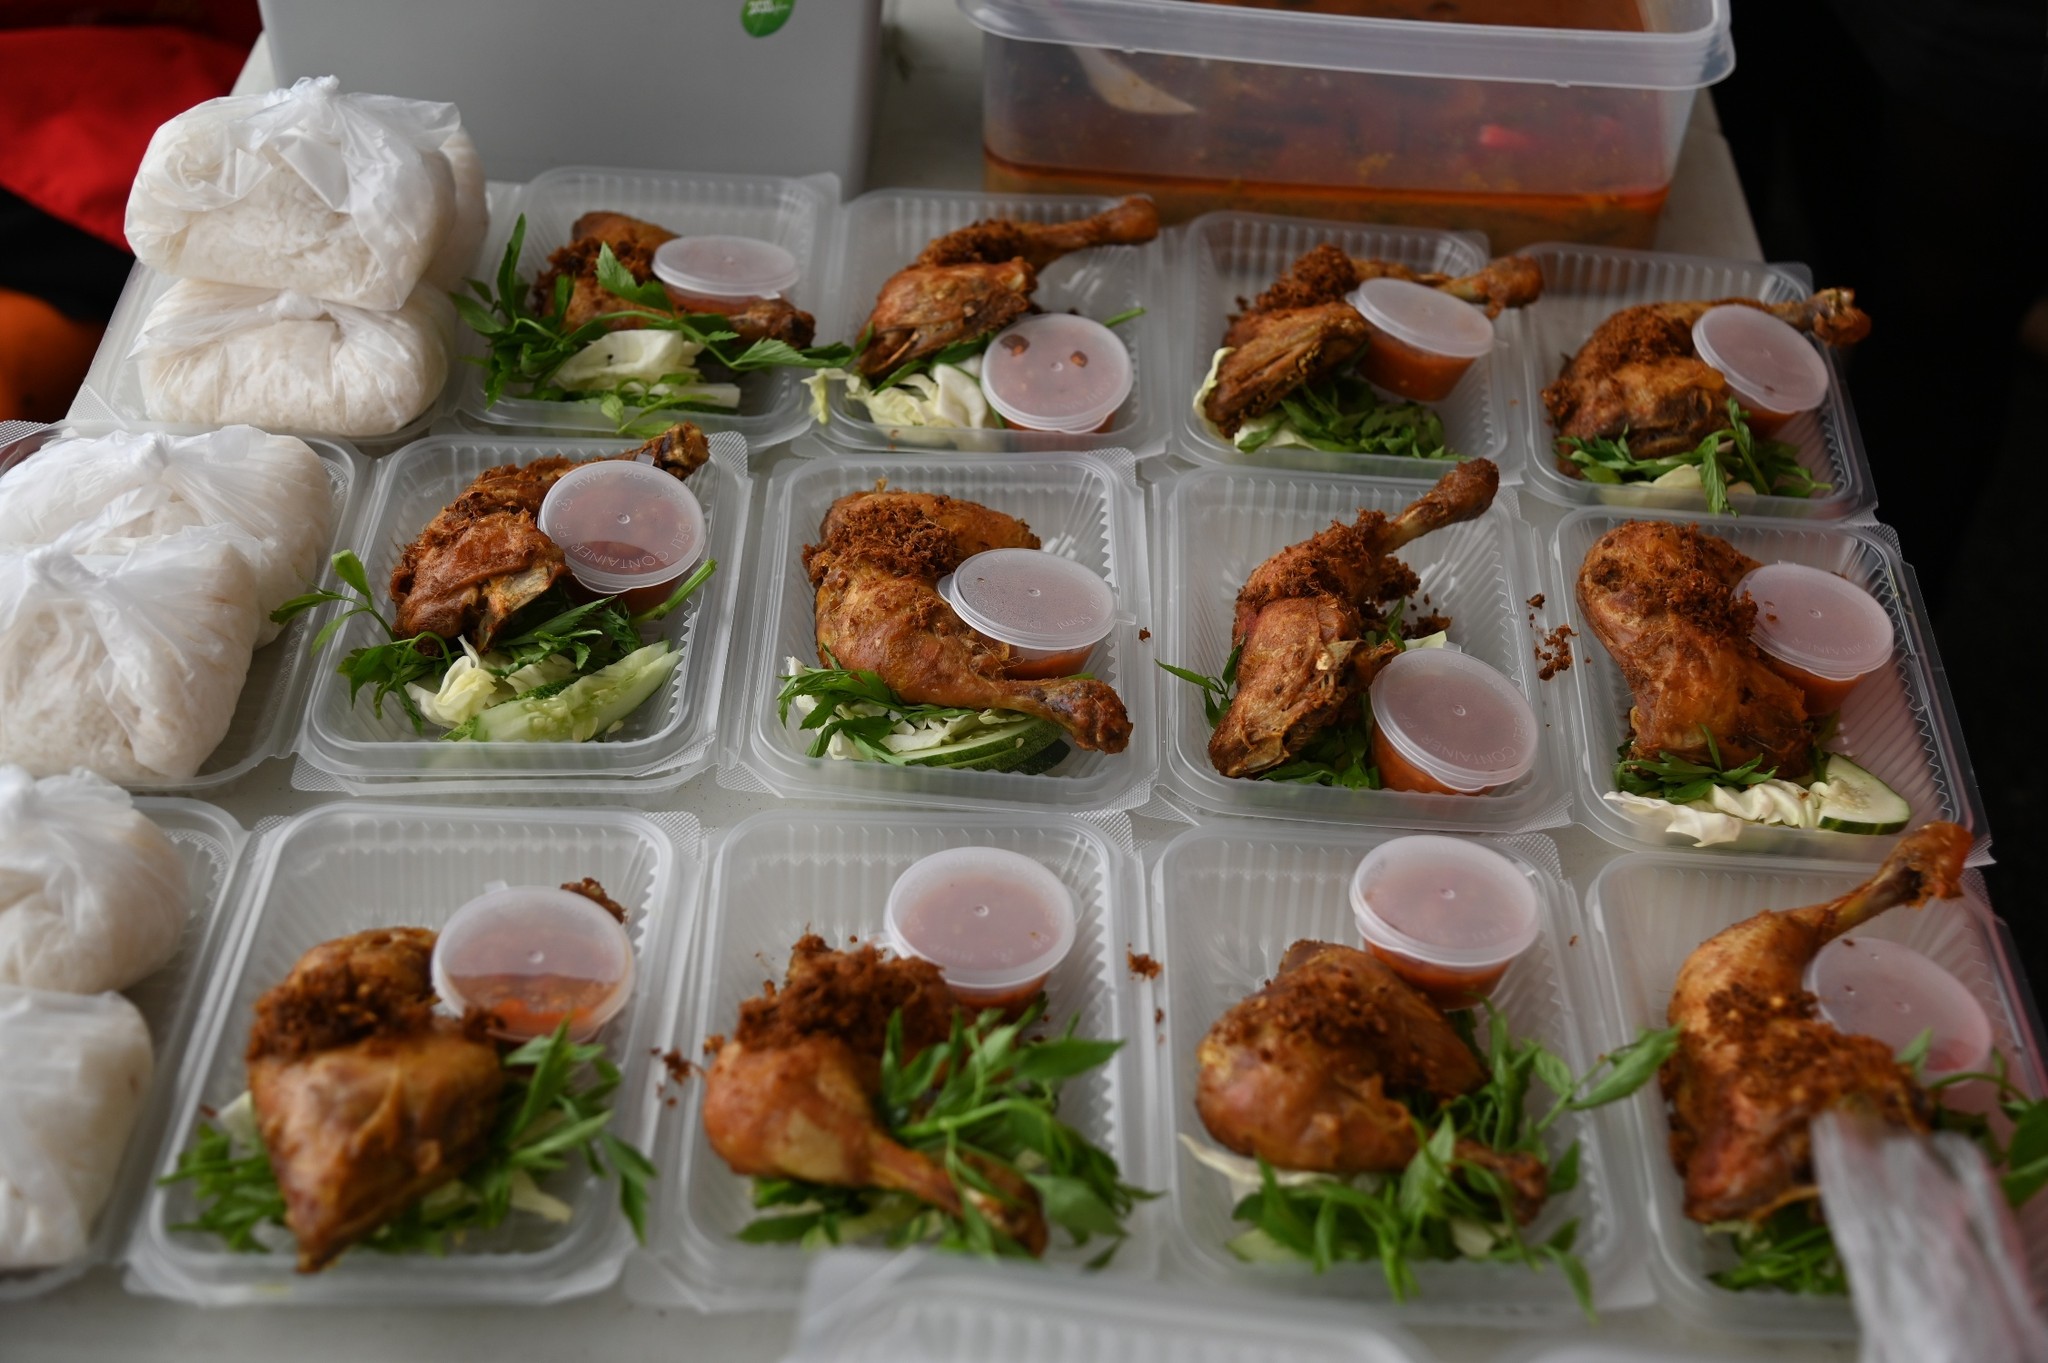Can you describe the dietary balance of the meals shown in the image? The meals shown are fairly balanced, featuring a combination of protein from the fried chicken, fiber and vitamins from the fresh greens, and carbohydrates from the rice. This setup seems designed to offer a fulfilling yet wholesome meal option. The inclusion of a sauce lends an extra layer of flavor, possibly adding a bit of fat for a satisfying meal experience. 